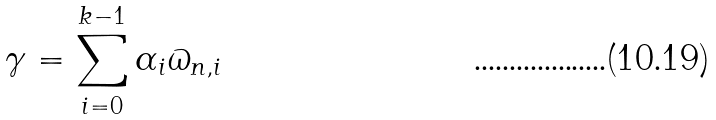<formula> <loc_0><loc_0><loc_500><loc_500>\gamma = \sum _ { i = 0 } ^ { k - 1 } \alpha _ { i } \varpi _ { n , i }</formula> 